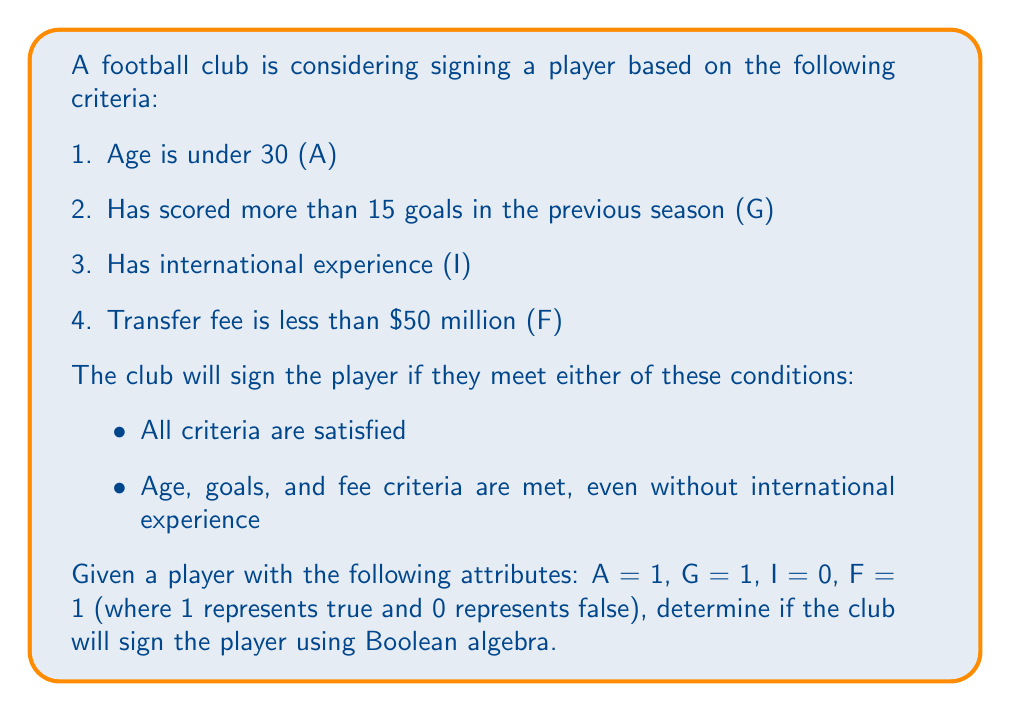Give your solution to this math problem. Let's approach this step-by-step using Boolean algebra:

1. First, let's express the two conditions as Boolean expressions:
   Condition 1: $A \land G \land I \land F$
   Condition 2: $A \land G \land F$

2. The club will sign the player if either of these conditions is met, so we can combine them using the OR operator:
   $(A \land G \land I \land F) \lor (A \land G \land F)$

3. We can simplify this expression using the distributive property:
   $A \land G \land F \land (I \lor 1)$

4. Since $I \lor 1 = 1$ (anything OR true is always true), we can further simplify:
   $A \land G \land F$

5. Now, let's substitute the given values:
   $1 \land 1 \land 1$

6. Evaluating:
   $1 \land 1 = 1$
   $1 \land 1 = 1$

Therefore, the final result is 1 (true).
Answer: True 